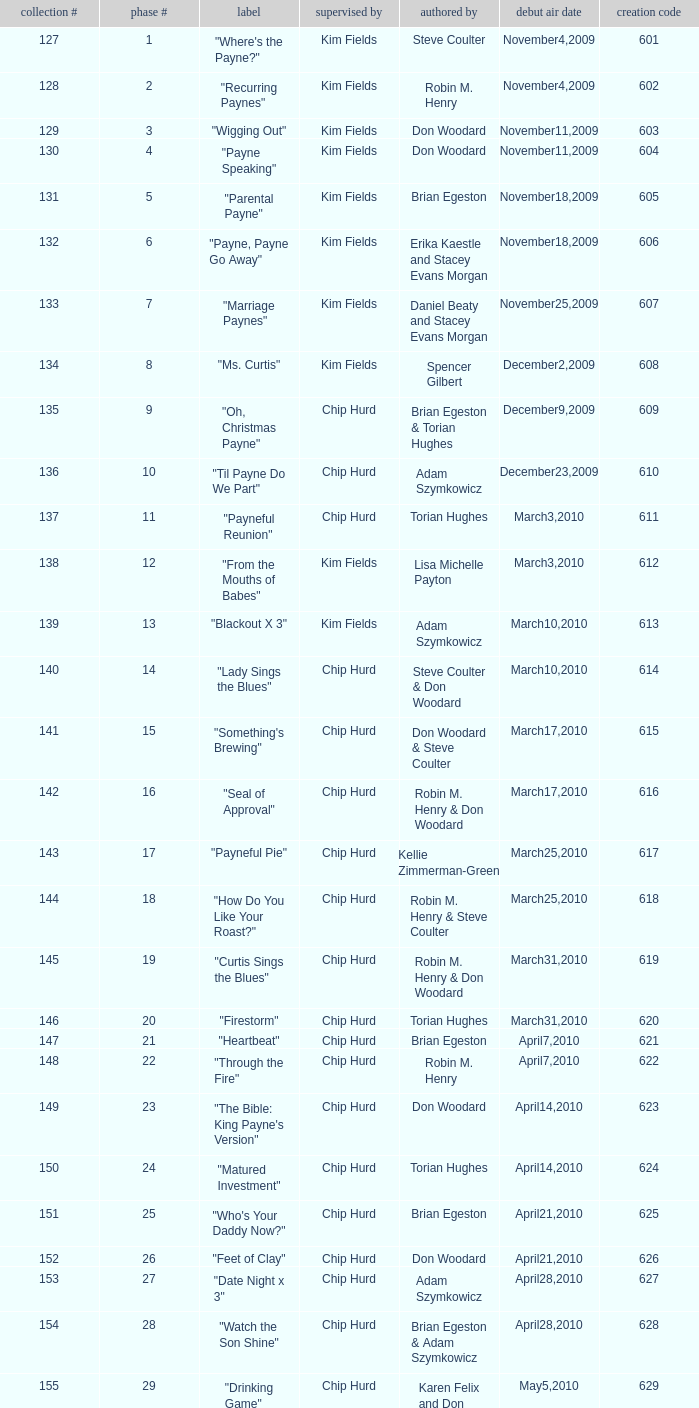What is the title of the episode with the production code 624? "Matured Investment". 